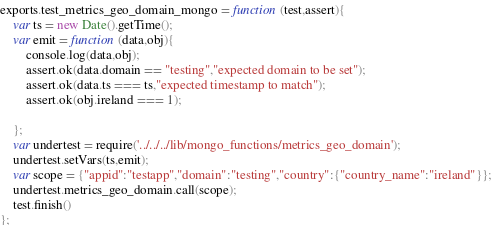<code> <loc_0><loc_0><loc_500><loc_500><_JavaScript_>
exports.test_metrics_geo_domain_mongo = function (test,assert){
    var ts = new Date().getTime();
    var emit = function (data,obj){
        console.log(data,obj);
        assert.ok(data.domain == "testing","expected domain to be set");
        assert.ok(data.ts === ts,"expected timestamp to match");
        assert.ok(obj.ireland === 1);

    };
    var undertest = require('../../../lib/mongo_functions/metrics_geo_domain');
    undertest.setVars(ts,emit);
    var scope = {"appid":"testapp","domain":"testing","country":{"country_name":"ireland"}};
    undertest.metrics_geo_domain.call(scope);
    test.finish()
};
</code> 